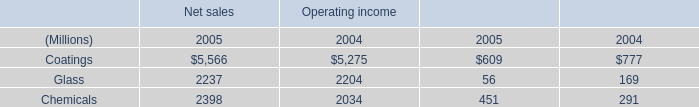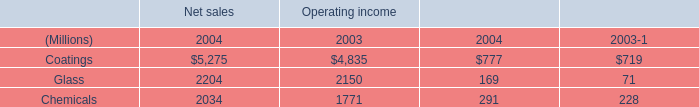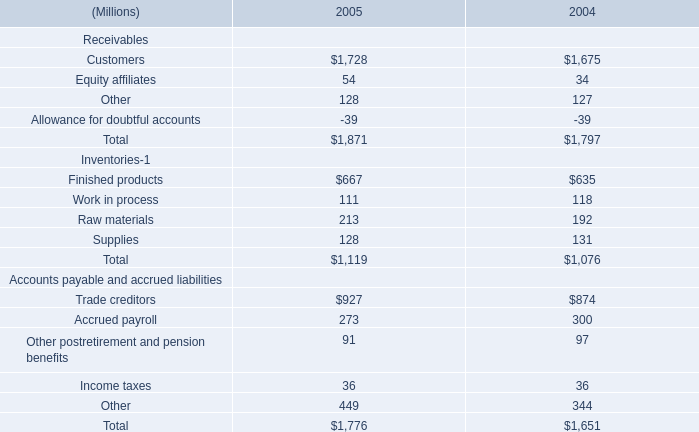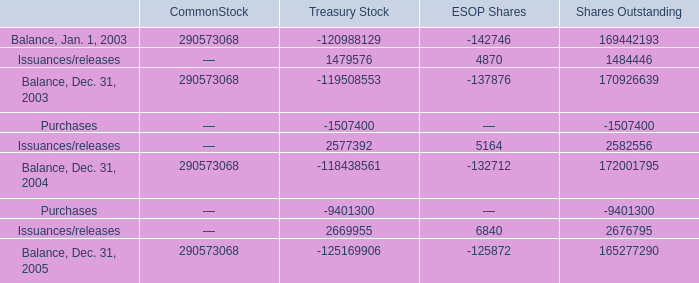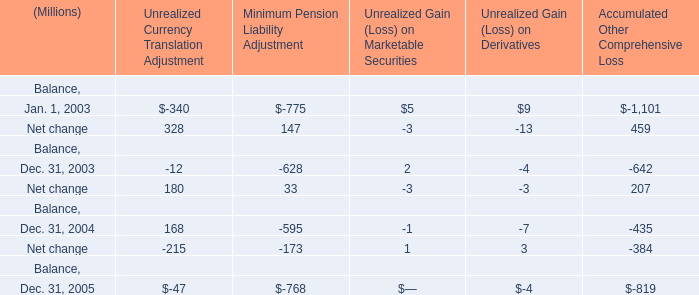what's the total amount of Balance, Dec. 31, 2003 of Treasury Stock, Glass of Operating income 2003, and Balance, Dec. 31, 2005 of ESOP Shares ? 
Computations: ((290573068.0 + 2150.0) + 125872.0)
Answer: 290701090.0. 